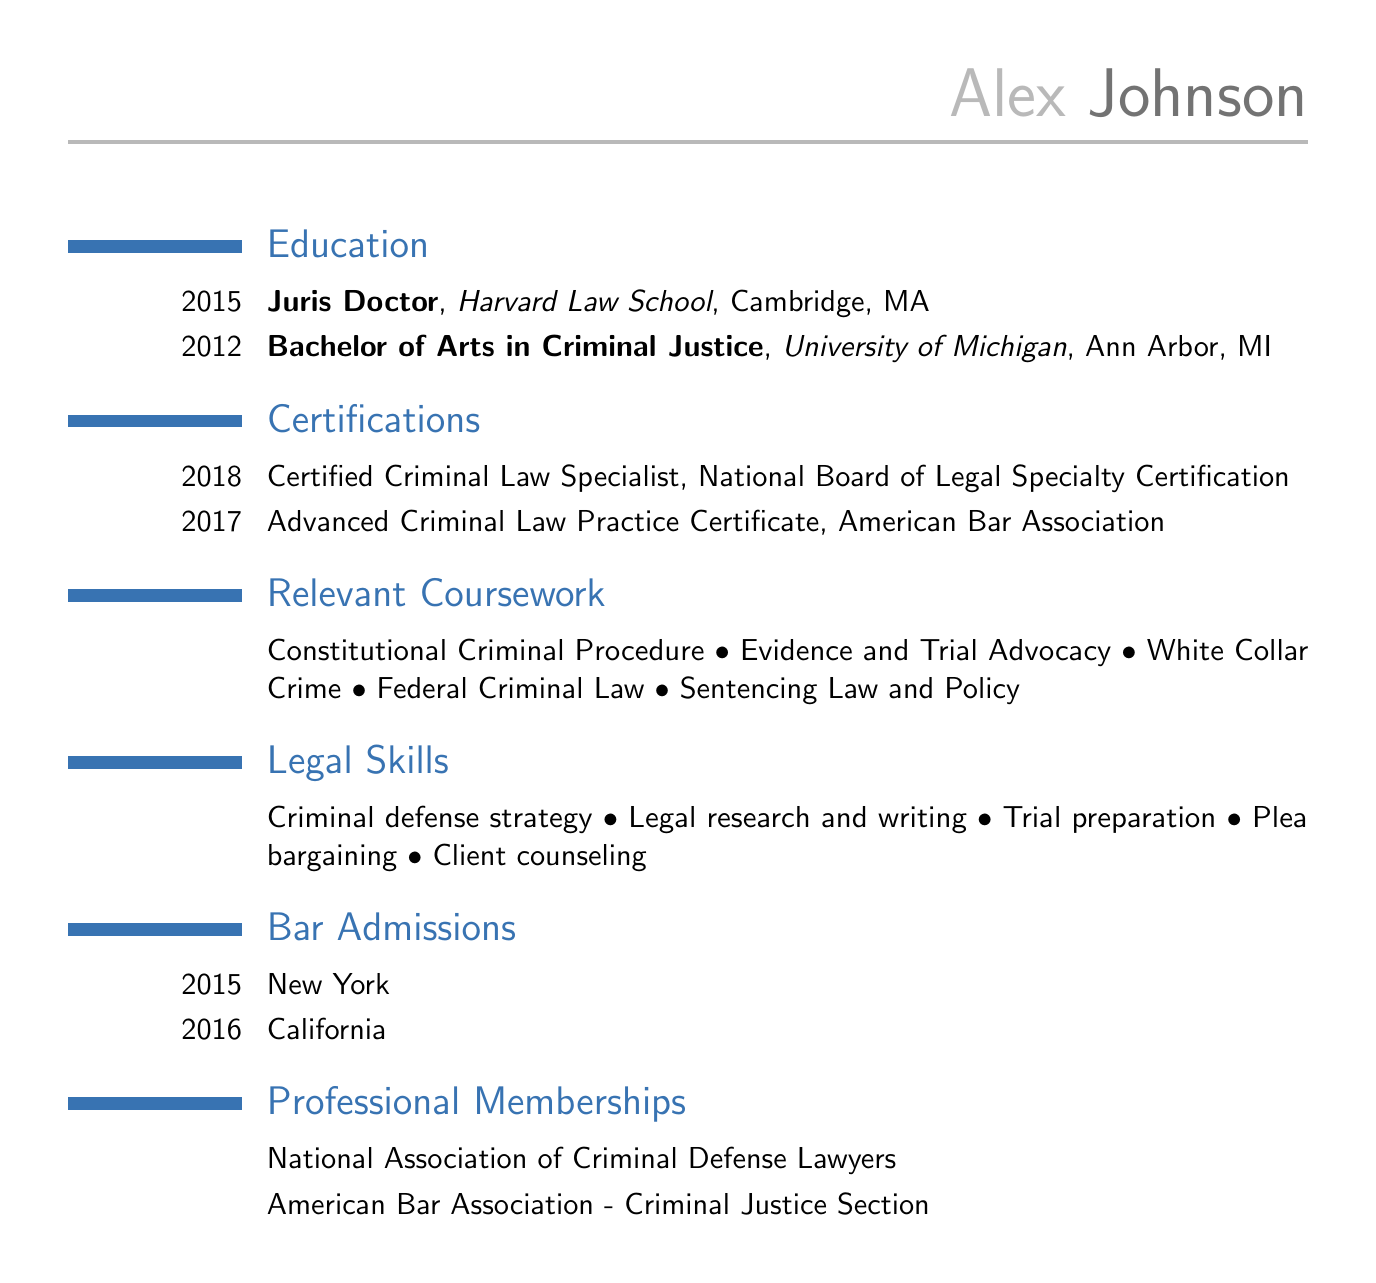What degree did Alex Johnson obtain in 2015? The document states that Alex Johnson earned a Juris Doctor degree in 2015 from Harvard Law School.
Answer: Juris Doctor Which institution did Alex attend for his Bachelor of Arts? The document indicates that Alex obtained his Bachelor of Arts in Criminal Justice from the University of Michigan.
Answer: University of Michigan What year did Alex receive the Certified Criminal Law Specialist certification? According to the document, Alex received this certification in 2018 from the National Board of Legal Specialty Certification.
Answer: 2018 In which state was Alex admitted to the bar in 2016? The document lists California as the state where Alex was admitted to the bar in 2016.
Answer: California How many relevant coursework topics are listed? There are five coursework topics mentioned under relevant coursework.
Answer: 5 What skill is directly associated with trial preparation? The document lists trial preparation as one of Alex’s legal skills.
Answer: Trial preparation What certification did Alex obtain from the American Bar Association in 2017? The document shows that Alex obtained the Advanced Criminal Law Practice Certificate from the American Bar Association in 2017.
Answer: Advanced Criminal Law Practice Certificate Which professional membership is associated with criminal defense lawyers? The document states that Alex is a member of the National Association of Criminal Defense Lawyers.
Answer: National Association of Criminal Defense Lawyers Which bar admission year is listed first in the document? The document lists the year 2015 first for the bar admission to New York.
Answer: 2015 